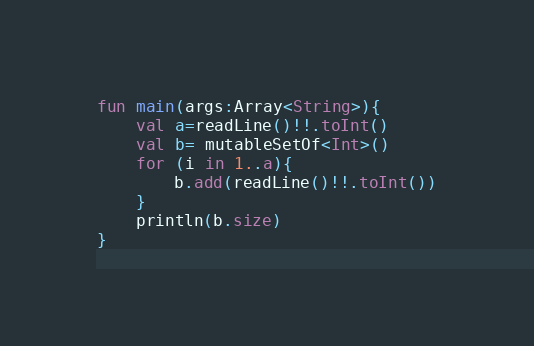Convert code to text. <code><loc_0><loc_0><loc_500><loc_500><_Kotlin_>fun main(args:Array<String>){
    val a=readLine()!!.toInt()
    val b= mutableSetOf<Int>()
    for (i in 1..a){
        b.add(readLine()!!.toInt())
    }
    println(b.size)
}</code> 